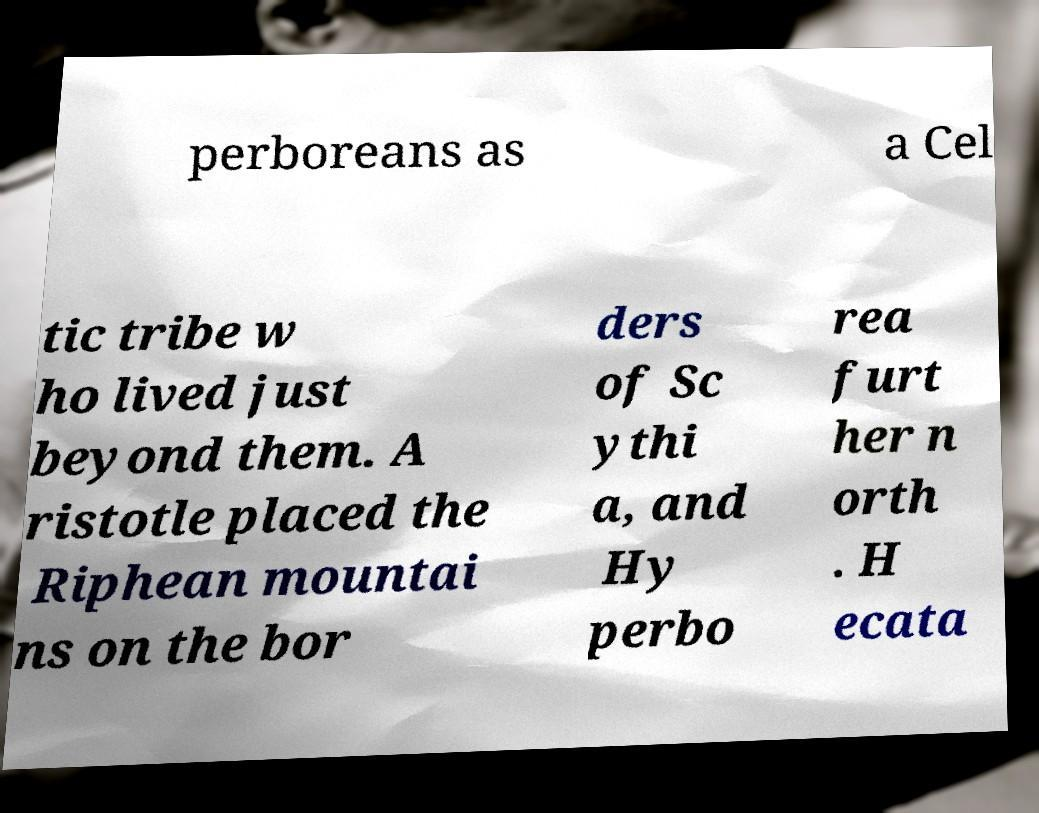Could you extract and type out the text from this image? perboreans as a Cel tic tribe w ho lived just beyond them. A ristotle placed the Riphean mountai ns on the bor ders of Sc ythi a, and Hy perbo rea furt her n orth . H ecata 